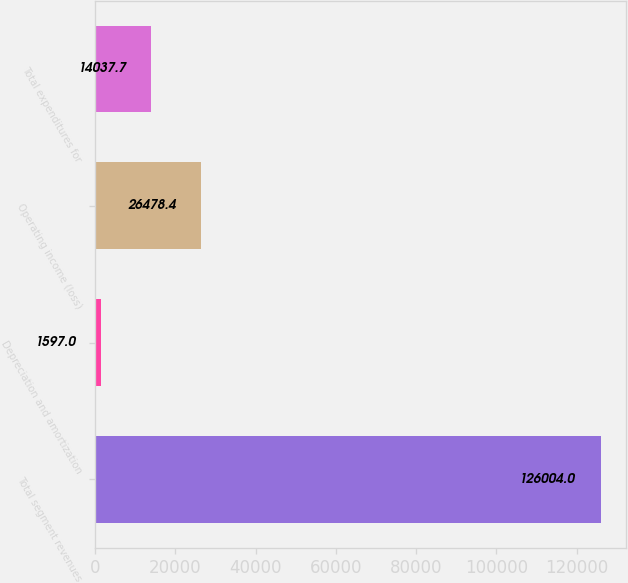Convert chart to OTSL. <chart><loc_0><loc_0><loc_500><loc_500><bar_chart><fcel>Total segment revenues<fcel>Depreciation and amortization<fcel>Operating income (loss)<fcel>Total expenditures for<nl><fcel>126004<fcel>1597<fcel>26478.4<fcel>14037.7<nl></chart> 